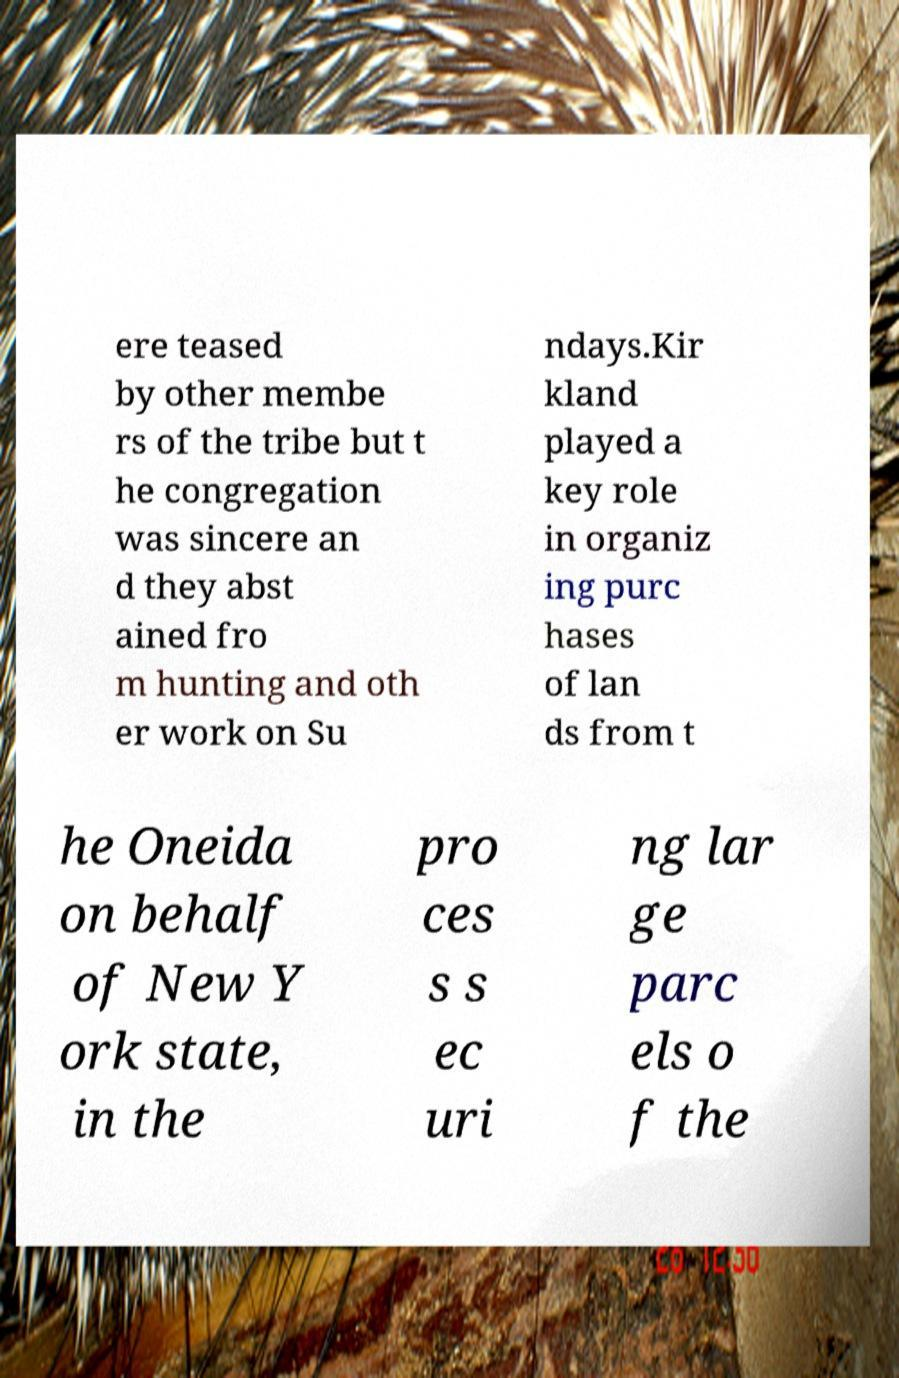Could you extract and type out the text from this image? ere teased by other membe rs of the tribe but t he congregation was sincere an d they abst ained fro m hunting and oth er work on Su ndays.Kir kland played a key role in organiz ing purc hases of lan ds from t he Oneida on behalf of New Y ork state, in the pro ces s s ec uri ng lar ge parc els o f the 